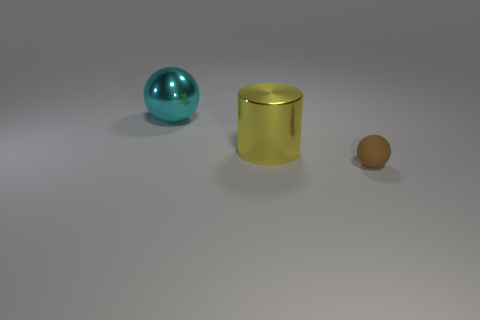Subtract all green balls. Subtract all green cylinders. How many balls are left? 2 Add 2 small balls. How many objects exist? 5 Subtract all cylinders. How many objects are left? 2 Add 1 tiny red cylinders. How many tiny red cylinders exist? 1 Subtract 1 brown spheres. How many objects are left? 2 Subtract all big brown rubber things. Subtract all large cyan things. How many objects are left? 2 Add 2 cyan metal balls. How many cyan metal balls are left? 3 